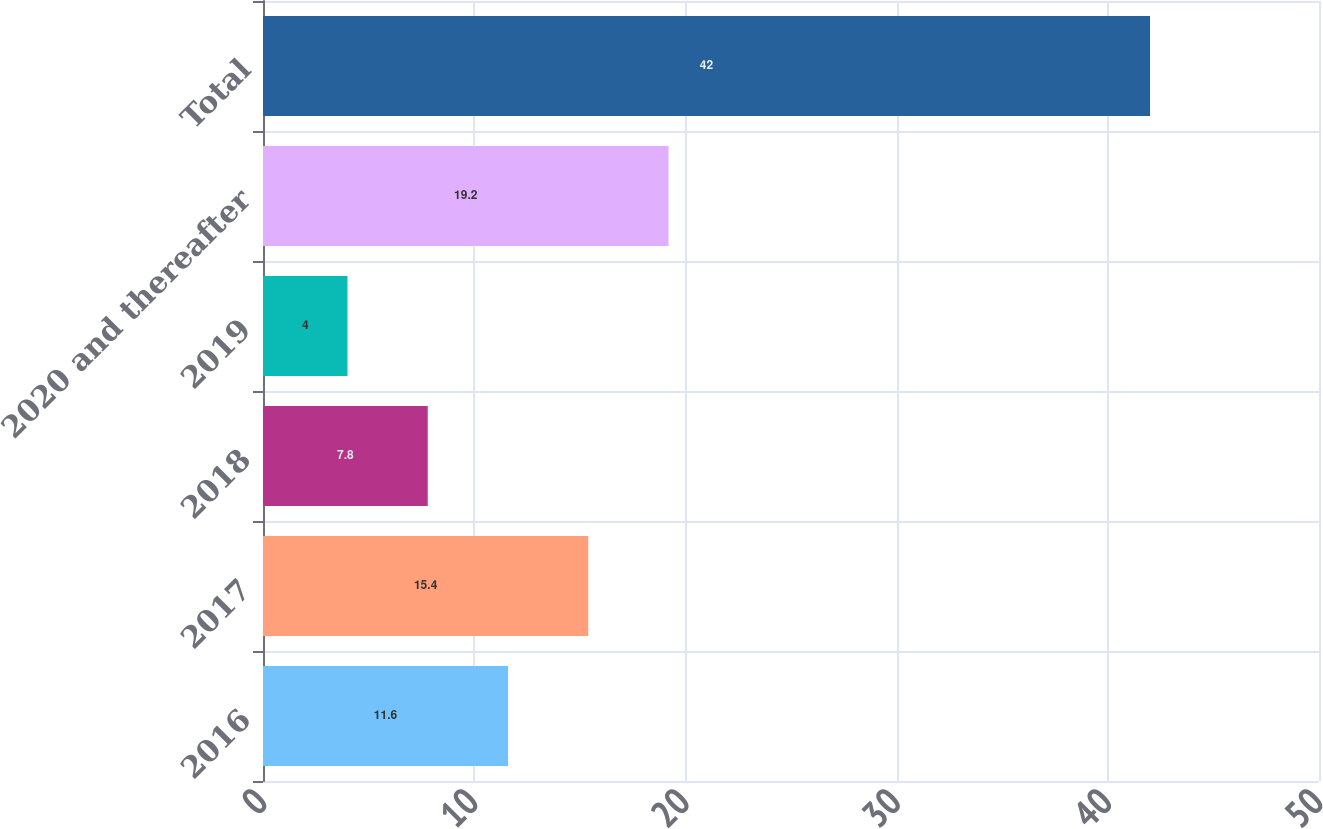Convert chart. <chart><loc_0><loc_0><loc_500><loc_500><bar_chart><fcel>2016<fcel>2017<fcel>2018<fcel>2019<fcel>2020 and thereafter<fcel>Total<nl><fcel>11.6<fcel>15.4<fcel>7.8<fcel>4<fcel>19.2<fcel>42<nl></chart> 